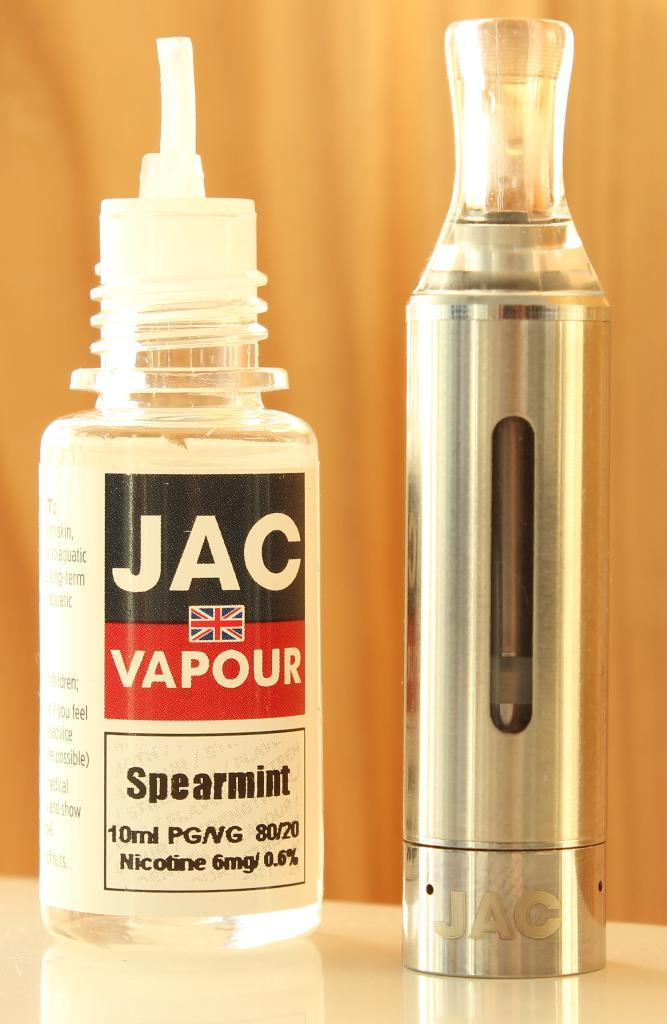<image>
Present a compact description of the photo's key features. An electronic cigarette is next to a bottle of spearmint refill fluid. 